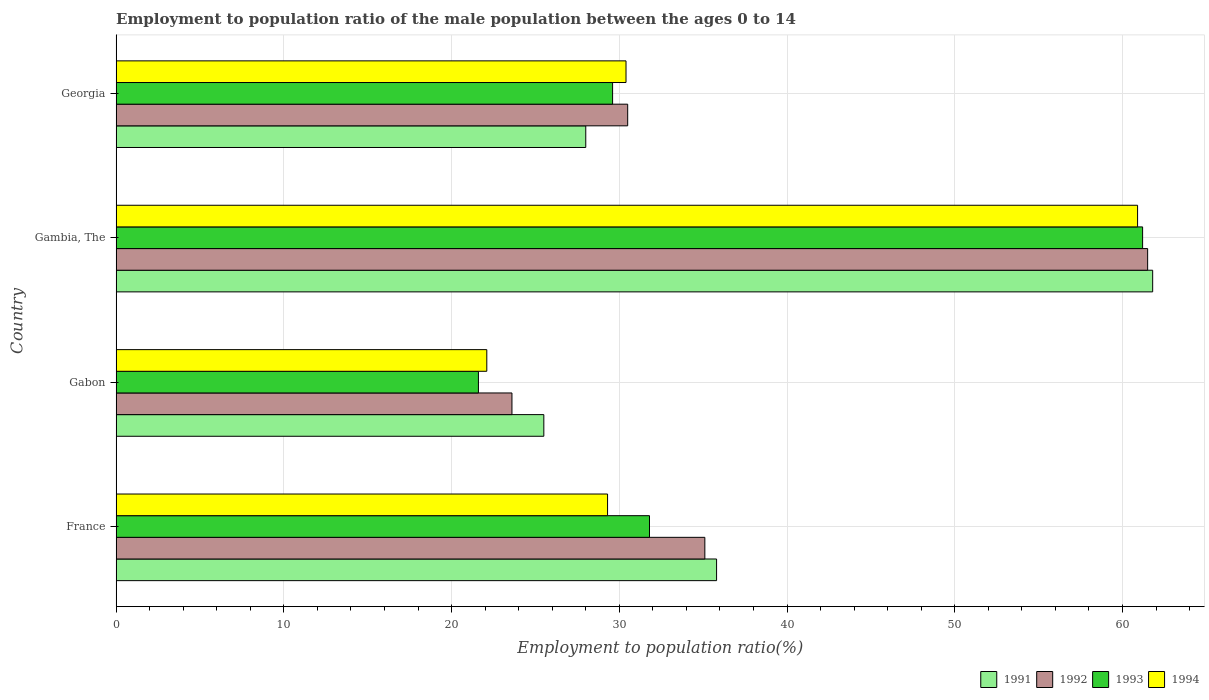How many bars are there on the 1st tick from the top?
Your answer should be very brief. 4. What is the label of the 2nd group of bars from the top?
Ensure brevity in your answer.  Gambia, The. What is the employment to population ratio in 1992 in Gambia, The?
Ensure brevity in your answer.  61.5. Across all countries, what is the maximum employment to population ratio in 1994?
Ensure brevity in your answer.  60.9. In which country was the employment to population ratio in 1992 maximum?
Provide a short and direct response. Gambia, The. In which country was the employment to population ratio in 1993 minimum?
Give a very brief answer. Gabon. What is the total employment to population ratio in 1992 in the graph?
Keep it short and to the point. 150.7. What is the difference between the employment to population ratio in 1992 in Gambia, The and that in Georgia?
Ensure brevity in your answer.  31. What is the difference between the employment to population ratio in 1992 in Gabon and the employment to population ratio in 1993 in Gambia, The?
Your answer should be very brief. -37.6. What is the average employment to population ratio in 1991 per country?
Your response must be concise. 37.77. What is the difference between the employment to population ratio in 1993 and employment to population ratio in 1991 in Georgia?
Provide a succinct answer. 1.6. In how many countries, is the employment to population ratio in 1993 greater than 60 %?
Your answer should be compact. 1. What is the ratio of the employment to population ratio in 1992 in Gambia, The to that in Georgia?
Your response must be concise. 2.02. Is the employment to population ratio in 1993 in France less than that in Gabon?
Ensure brevity in your answer.  No. What is the difference between the highest and the second highest employment to population ratio in 1992?
Your answer should be very brief. 26.4. What is the difference between the highest and the lowest employment to population ratio in 1992?
Keep it short and to the point. 37.9. What does the 3rd bar from the top in Gambia, The represents?
Your answer should be compact. 1992. How many countries are there in the graph?
Provide a succinct answer. 4. What is the difference between two consecutive major ticks on the X-axis?
Offer a very short reply. 10. Does the graph contain any zero values?
Make the answer very short. No. Where does the legend appear in the graph?
Provide a short and direct response. Bottom right. How many legend labels are there?
Provide a succinct answer. 4. How are the legend labels stacked?
Make the answer very short. Horizontal. What is the title of the graph?
Your answer should be very brief. Employment to population ratio of the male population between the ages 0 to 14. What is the label or title of the Y-axis?
Make the answer very short. Country. What is the Employment to population ratio(%) of 1991 in France?
Offer a terse response. 35.8. What is the Employment to population ratio(%) in 1992 in France?
Keep it short and to the point. 35.1. What is the Employment to population ratio(%) in 1993 in France?
Give a very brief answer. 31.8. What is the Employment to population ratio(%) in 1994 in France?
Offer a terse response. 29.3. What is the Employment to population ratio(%) of 1991 in Gabon?
Give a very brief answer. 25.5. What is the Employment to population ratio(%) in 1992 in Gabon?
Your answer should be compact. 23.6. What is the Employment to population ratio(%) of 1993 in Gabon?
Your answer should be compact. 21.6. What is the Employment to population ratio(%) in 1994 in Gabon?
Keep it short and to the point. 22.1. What is the Employment to population ratio(%) of 1991 in Gambia, The?
Give a very brief answer. 61.8. What is the Employment to population ratio(%) of 1992 in Gambia, The?
Your response must be concise. 61.5. What is the Employment to population ratio(%) of 1993 in Gambia, The?
Offer a very short reply. 61.2. What is the Employment to population ratio(%) of 1994 in Gambia, The?
Make the answer very short. 60.9. What is the Employment to population ratio(%) in 1992 in Georgia?
Offer a terse response. 30.5. What is the Employment to population ratio(%) of 1993 in Georgia?
Provide a succinct answer. 29.6. What is the Employment to population ratio(%) of 1994 in Georgia?
Offer a very short reply. 30.4. Across all countries, what is the maximum Employment to population ratio(%) in 1991?
Make the answer very short. 61.8. Across all countries, what is the maximum Employment to population ratio(%) in 1992?
Make the answer very short. 61.5. Across all countries, what is the maximum Employment to population ratio(%) of 1993?
Your response must be concise. 61.2. Across all countries, what is the maximum Employment to population ratio(%) of 1994?
Provide a short and direct response. 60.9. Across all countries, what is the minimum Employment to population ratio(%) in 1992?
Provide a short and direct response. 23.6. Across all countries, what is the minimum Employment to population ratio(%) of 1993?
Make the answer very short. 21.6. Across all countries, what is the minimum Employment to population ratio(%) in 1994?
Provide a succinct answer. 22.1. What is the total Employment to population ratio(%) of 1991 in the graph?
Give a very brief answer. 151.1. What is the total Employment to population ratio(%) of 1992 in the graph?
Provide a short and direct response. 150.7. What is the total Employment to population ratio(%) in 1993 in the graph?
Provide a short and direct response. 144.2. What is the total Employment to population ratio(%) of 1994 in the graph?
Provide a succinct answer. 142.7. What is the difference between the Employment to population ratio(%) in 1992 in France and that in Gabon?
Ensure brevity in your answer.  11.5. What is the difference between the Employment to population ratio(%) of 1993 in France and that in Gabon?
Provide a succinct answer. 10.2. What is the difference between the Employment to population ratio(%) in 1994 in France and that in Gabon?
Your answer should be compact. 7.2. What is the difference between the Employment to population ratio(%) in 1992 in France and that in Gambia, The?
Provide a succinct answer. -26.4. What is the difference between the Employment to population ratio(%) of 1993 in France and that in Gambia, The?
Keep it short and to the point. -29.4. What is the difference between the Employment to population ratio(%) of 1994 in France and that in Gambia, The?
Offer a very short reply. -31.6. What is the difference between the Employment to population ratio(%) in 1991 in Gabon and that in Gambia, The?
Give a very brief answer. -36.3. What is the difference between the Employment to population ratio(%) in 1992 in Gabon and that in Gambia, The?
Offer a terse response. -37.9. What is the difference between the Employment to population ratio(%) of 1993 in Gabon and that in Gambia, The?
Provide a short and direct response. -39.6. What is the difference between the Employment to population ratio(%) in 1994 in Gabon and that in Gambia, The?
Your answer should be compact. -38.8. What is the difference between the Employment to population ratio(%) of 1993 in Gabon and that in Georgia?
Offer a terse response. -8. What is the difference between the Employment to population ratio(%) in 1991 in Gambia, The and that in Georgia?
Provide a succinct answer. 33.8. What is the difference between the Employment to population ratio(%) of 1993 in Gambia, The and that in Georgia?
Your answer should be very brief. 31.6. What is the difference between the Employment to population ratio(%) of 1994 in Gambia, The and that in Georgia?
Ensure brevity in your answer.  30.5. What is the difference between the Employment to population ratio(%) of 1991 in France and the Employment to population ratio(%) of 1994 in Gabon?
Provide a succinct answer. 13.7. What is the difference between the Employment to population ratio(%) of 1992 in France and the Employment to population ratio(%) of 1993 in Gabon?
Your answer should be very brief. 13.5. What is the difference between the Employment to population ratio(%) in 1992 in France and the Employment to population ratio(%) in 1994 in Gabon?
Ensure brevity in your answer.  13. What is the difference between the Employment to population ratio(%) of 1991 in France and the Employment to population ratio(%) of 1992 in Gambia, The?
Ensure brevity in your answer.  -25.7. What is the difference between the Employment to population ratio(%) of 1991 in France and the Employment to population ratio(%) of 1993 in Gambia, The?
Make the answer very short. -25.4. What is the difference between the Employment to population ratio(%) of 1991 in France and the Employment to population ratio(%) of 1994 in Gambia, The?
Give a very brief answer. -25.1. What is the difference between the Employment to population ratio(%) in 1992 in France and the Employment to population ratio(%) in 1993 in Gambia, The?
Offer a very short reply. -26.1. What is the difference between the Employment to population ratio(%) in 1992 in France and the Employment to population ratio(%) in 1994 in Gambia, The?
Your answer should be compact. -25.8. What is the difference between the Employment to population ratio(%) in 1993 in France and the Employment to population ratio(%) in 1994 in Gambia, The?
Your answer should be compact. -29.1. What is the difference between the Employment to population ratio(%) in 1991 in France and the Employment to population ratio(%) in 1992 in Georgia?
Your answer should be very brief. 5.3. What is the difference between the Employment to population ratio(%) in 1992 in France and the Employment to population ratio(%) in 1993 in Georgia?
Ensure brevity in your answer.  5.5. What is the difference between the Employment to population ratio(%) in 1991 in Gabon and the Employment to population ratio(%) in 1992 in Gambia, The?
Provide a succinct answer. -36. What is the difference between the Employment to population ratio(%) in 1991 in Gabon and the Employment to population ratio(%) in 1993 in Gambia, The?
Ensure brevity in your answer.  -35.7. What is the difference between the Employment to population ratio(%) in 1991 in Gabon and the Employment to population ratio(%) in 1994 in Gambia, The?
Your response must be concise. -35.4. What is the difference between the Employment to population ratio(%) in 1992 in Gabon and the Employment to population ratio(%) in 1993 in Gambia, The?
Provide a short and direct response. -37.6. What is the difference between the Employment to population ratio(%) of 1992 in Gabon and the Employment to population ratio(%) of 1994 in Gambia, The?
Give a very brief answer. -37.3. What is the difference between the Employment to population ratio(%) of 1993 in Gabon and the Employment to population ratio(%) of 1994 in Gambia, The?
Give a very brief answer. -39.3. What is the difference between the Employment to population ratio(%) in 1991 in Gabon and the Employment to population ratio(%) in 1992 in Georgia?
Provide a succinct answer. -5. What is the difference between the Employment to population ratio(%) in 1991 in Gabon and the Employment to population ratio(%) in 1994 in Georgia?
Provide a short and direct response. -4.9. What is the difference between the Employment to population ratio(%) in 1992 in Gabon and the Employment to population ratio(%) in 1993 in Georgia?
Keep it short and to the point. -6. What is the difference between the Employment to population ratio(%) in 1993 in Gabon and the Employment to population ratio(%) in 1994 in Georgia?
Your answer should be very brief. -8.8. What is the difference between the Employment to population ratio(%) in 1991 in Gambia, The and the Employment to population ratio(%) in 1992 in Georgia?
Offer a terse response. 31.3. What is the difference between the Employment to population ratio(%) of 1991 in Gambia, The and the Employment to population ratio(%) of 1993 in Georgia?
Provide a short and direct response. 32.2. What is the difference between the Employment to population ratio(%) in 1991 in Gambia, The and the Employment to population ratio(%) in 1994 in Georgia?
Your answer should be very brief. 31.4. What is the difference between the Employment to population ratio(%) in 1992 in Gambia, The and the Employment to population ratio(%) in 1993 in Georgia?
Make the answer very short. 31.9. What is the difference between the Employment to population ratio(%) in 1992 in Gambia, The and the Employment to population ratio(%) in 1994 in Georgia?
Your answer should be compact. 31.1. What is the difference between the Employment to population ratio(%) in 1993 in Gambia, The and the Employment to population ratio(%) in 1994 in Georgia?
Offer a terse response. 30.8. What is the average Employment to population ratio(%) of 1991 per country?
Ensure brevity in your answer.  37.77. What is the average Employment to population ratio(%) in 1992 per country?
Your answer should be compact. 37.67. What is the average Employment to population ratio(%) in 1993 per country?
Your answer should be very brief. 36.05. What is the average Employment to population ratio(%) in 1994 per country?
Offer a very short reply. 35.67. What is the difference between the Employment to population ratio(%) in 1991 and Employment to population ratio(%) in 1994 in France?
Your answer should be very brief. 6.5. What is the difference between the Employment to population ratio(%) of 1993 and Employment to population ratio(%) of 1994 in France?
Give a very brief answer. 2.5. What is the difference between the Employment to population ratio(%) in 1991 and Employment to population ratio(%) in 1994 in Gabon?
Offer a very short reply. 3.4. What is the difference between the Employment to population ratio(%) of 1993 and Employment to population ratio(%) of 1994 in Gabon?
Provide a short and direct response. -0.5. What is the difference between the Employment to population ratio(%) of 1991 and Employment to population ratio(%) of 1994 in Gambia, The?
Make the answer very short. 0.9. What is the difference between the Employment to population ratio(%) in 1992 and Employment to population ratio(%) in 1994 in Gambia, The?
Your response must be concise. 0.6. What is the difference between the Employment to population ratio(%) in 1992 and Employment to population ratio(%) in 1994 in Georgia?
Provide a succinct answer. 0.1. What is the difference between the Employment to population ratio(%) of 1993 and Employment to population ratio(%) of 1994 in Georgia?
Keep it short and to the point. -0.8. What is the ratio of the Employment to population ratio(%) of 1991 in France to that in Gabon?
Provide a short and direct response. 1.4. What is the ratio of the Employment to population ratio(%) of 1992 in France to that in Gabon?
Offer a very short reply. 1.49. What is the ratio of the Employment to population ratio(%) in 1993 in France to that in Gabon?
Offer a very short reply. 1.47. What is the ratio of the Employment to population ratio(%) in 1994 in France to that in Gabon?
Offer a very short reply. 1.33. What is the ratio of the Employment to population ratio(%) in 1991 in France to that in Gambia, The?
Provide a succinct answer. 0.58. What is the ratio of the Employment to population ratio(%) in 1992 in France to that in Gambia, The?
Your answer should be very brief. 0.57. What is the ratio of the Employment to population ratio(%) in 1993 in France to that in Gambia, The?
Ensure brevity in your answer.  0.52. What is the ratio of the Employment to population ratio(%) in 1994 in France to that in Gambia, The?
Offer a very short reply. 0.48. What is the ratio of the Employment to population ratio(%) in 1991 in France to that in Georgia?
Your response must be concise. 1.28. What is the ratio of the Employment to population ratio(%) of 1992 in France to that in Georgia?
Give a very brief answer. 1.15. What is the ratio of the Employment to population ratio(%) in 1993 in France to that in Georgia?
Make the answer very short. 1.07. What is the ratio of the Employment to population ratio(%) of 1994 in France to that in Georgia?
Your answer should be compact. 0.96. What is the ratio of the Employment to population ratio(%) in 1991 in Gabon to that in Gambia, The?
Offer a terse response. 0.41. What is the ratio of the Employment to population ratio(%) of 1992 in Gabon to that in Gambia, The?
Offer a terse response. 0.38. What is the ratio of the Employment to population ratio(%) of 1993 in Gabon to that in Gambia, The?
Ensure brevity in your answer.  0.35. What is the ratio of the Employment to population ratio(%) of 1994 in Gabon to that in Gambia, The?
Give a very brief answer. 0.36. What is the ratio of the Employment to population ratio(%) in 1991 in Gabon to that in Georgia?
Give a very brief answer. 0.91. What is the ratio of the Employment to population ratio(%) in 1992 in Gabon to that in Georgia?
Your answer should be compact. 0.77. What is the ratio of the Employment to population ratio(%) in 1993 in Gabon to that in Georgia?
Ensure brevity in your answer.  0.73. What is the ratio of the Employment to population ratio(%) of 1994 in Gabon to that in Georgia?
Give a very brief answer. 0.73. What is the ratio of the Employment to population ratio(%) in 1991 in Gambia, The to that in Georgia?
Your answer should be very brief. 2.21. What is the ratio of the Employment to population ratio(%) of 1992 in Gambia, The to that in Georgia?
Keep it short and to the point. 2.02. What is the ratio of the Employment to population ratio(%) of 1993 in Gambia, The to that in Georgia?
Offer a very short reply. 2.07. What is the ratio of the Employment to population ratio(%) in 1994 in Gambia, The to that in Georgia?
Ensure brevity in your answer.  2. What is the difference between the highest and the second highest Employment to population ratio(%) of 1991?
Offer a very short reply. 26. What is the difference between the highest and the second highest Employment to population ratio(%) of 1992?
Your response must be concise. 26.4. What is the difference between the highest and the second highest Employment to population ratio(%) in 1993?
Offer a terse response. 29.4. What is the difference between the highest and the second highest Employment to population ratio(%) in 1994?
Offer a terse response. 30.5. What is the difference between the highest and the lowest Employment to population ratio(%) in 1991?
Your answer should be very brief. 36.3. What is the difference between the highest and the lowest Employment to population ratio(%) in 1992?
Provide a succinct answer. 37.9. What is the difference between the highest and the lowest Employment to population ratio(%) in 1993?
Provide a short and direct response. 39.6. What is the difference between the highest and the lowest Employment to population ratio(%) in 1994?
Make the answer very short. 38.8. 